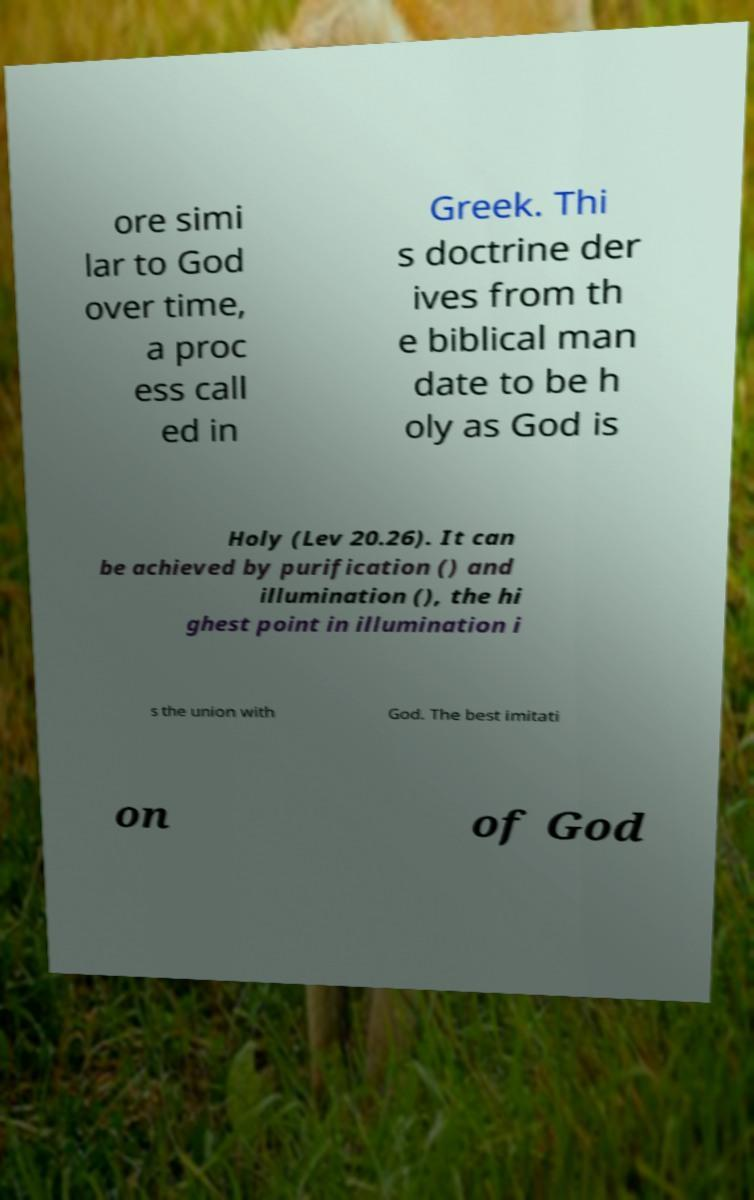I need the written content from this picture converted into text. Can you do that? ore simi lar to God over time, a proc ess call ed in Greek. Thi s doctrine der ives from th e biblical man date to be h oly as God is Holy (Lev 20.26). It can be achieved by purification () and illumination (), the hi ghest point in illumination i s the union with God. The best imitati on of God 